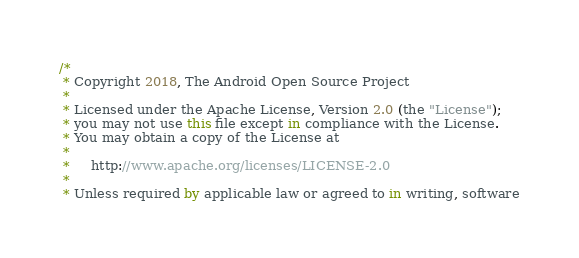Convert code to text. <code><loc_0><loc_0><loc_500><loc_500><_Kotlin_>/*
 * Copyright 2018, The Android Open Source Project
 *
 * Licensed under the Apache License, Version 2.0 (the "License");
 * you may not use this file except in compliance with the License.
 * You may obtain a copy of the License at
 *
 *     http://www.apache.org/licenses/LICENSE-2.0
 *
 * Unless required by applicable law or agreed to in writing, software</code> 